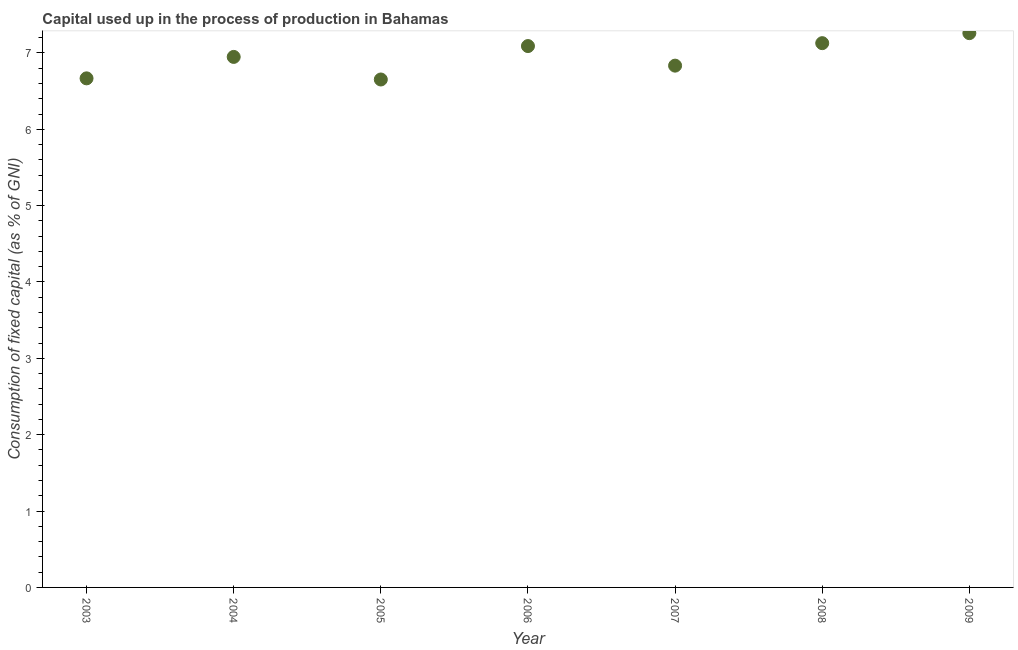What is the consumption of fixed capital in 2008?
Provide a succinct answer. 7.13. Across all years, what is the maximum consumption of fixed capital?
Provide a succinct answer. 7.26. Across all years, what is the minimum consumption of fixed capital?
Ensure brevity in your answer.  6.65. In which year was the consumption of fixed capital minimum?
Keep it short and to the point. 2005. What is the sum of the consumption of fixed capital?
Provide a succinct answer. 48.58. What is the difference between the consumption of fixed capital in 2005 and 2006?
Offer a very short reply. -0.44. What is the average consumption of fixed capital per year?
Ensure brevity in your answer.  6.94. What is the median consumption of fixed capital?
Your answer should be compact. 6.95. What is the ratio of the consumption of fixed capital in 2007 to that in 2009?
Provide a short and direct response. 0.94. Is the consumption of fixed capital in 2004 less than that in 2008?
Give a very brief answer. Yes. Is the difference between the consumption of fixed capital in 2005 and 2008 greater than the difference between any two years?
Give a very brief answer. No. What is the difference between the highest and the second highest consumption of fixed capital?
Make the answer very short. 0.13. What is the difference between the highest and the lowest consumption of fixed capital?
Offer a terse response. 0.61. In how many years, is the consumption of fixed capital greater than the average consumption of fixed capital taken over all years?
Give a very brief answer. 4. How many dotlines are there?
Your response must be concise. 1. What is the difference between two consecutive major ticks on the Y-axis?
Provide a succinct answer. 1. Are the values on the major ticks of Y-axis written in scientific E-notation?
Offer a very short reply. No. Does the graph contain any zero values?
Your answer should be very brief. No. Does the graph contain grids?
Give a very brief answer. No. What is the title of the graph?
Your answer should be compact. Capital used up in the process of production in Bahamas. What is the label or title of the Y-axis?
Ensure brevity in your answer.  Consumption of fixed capital (as % of GNI). What is the Consumption of fixed capital (as % of GNI) in 2003?
Your answer should be compact. 6.67. What is the Consumption of fixed capital (as % of GNI) in 2004?
Offer a terse response. 6.95. What is the Consumption of fixed capital (as % of GNI) in 2005?
Your response must be concise. 6.65. What is the Consumption of fixed capital (as % of GNI) in 2006?
Offer a terse response. 7.09. What is the Consumption of fixed capital (as % of GNI) in 2007?
Your answer should be compact. 6.83. What is the Consumption of fixed capital (as % of GNI) in 2008?
Offer a very short reply. 7.13. What is the Consumption of fixed capital (as % of GNI) in 2009?
Keep it short and to the point. 7.26. What is the difference between the Consumption of fixed capital (as % of GNI) in 2003 and 2004?
Offer a terse response. -0.28. What is the difference between the Consumption of fixed capital (as % of GNI) in 2003 and 2005?
Give a very brief answer. 0.01. What is the difference between the Consumption of fixed capital (as % of GNI) in 2003 and 2006?
Your response must be concise. -0.42. What is the difference between the Consumption of fixed capital (as % of GNI) in 2003 and 2007?
Provide a succinct answer. -0.17. What is the difference between the Consumption of fixed capital (as % of GNI) in 2003 and 2008?
Keep it short and to the point. -0.46. What is the difference between the Consumption of fixed capital (as % of GNI) in 2003 and 2009?
Ensure brevity in your answer.  -0.59. What is the difference between the Consumption of fixed capital (as % of GNI) in 2004 and 2005?
Your answer should be very brief. 0.3. What is the difference between the Consumption of fixed capital (as % of GNI) in 2004 and 2006?
Keep it short and to the point. -0.14. What is the difference between the Consumption of fixed capital (as % of GNI) in 2004 and 2007?
Your response must be concise. 0.11. What is the difference between the Consumption of fixed capital (as % of GNI) in 2004 and 2008?
Offer a terse response. -0.18. What is the difference between the Consumption of fixed capital (as % of GNI) in 2004 and 2009?
Provide a succinct answer. -0.31. What is the difference between the Consumption of fixed capital (as % of GNI) in 2005 and 2006?
Make the answer very short. -0.44. What is the difference between the Consumption of fixed capital (as % of GNI) in 2005 and 2007?
Keep it short and to the point. -0.18. What is the difference between the Consumption of fixed capital (as % of GNI) in 2005 and 2008?
Your answer should be compact. -0.48. What is the difference between the Consumption of fixed capital (as % of GNI) in 2005 and 2009?
Your response must be concise. -0.61. What is the difference between the Consumption of fixed capital (as % of GNI) in 2006 and 2007?
Offer a terse response. 0.26. What is the difference between the Consumption of fixed capital (as % of GNI) in 2006 and 2008?
Keep it short and to the point. -0.04. What is the difference between the Consumption of fixed capital (as % of GNI) in 2006 and 2009?
Provide a short and direct response. -0.17. What is the difference between the Consumption of fixed capital (as % of GNI) in 2007 and 2008?
Your response must be concise. -0.29. What is the difference between the Consumption of fixed capital (as % of GNI) in 2007 and 2009?
Your response must be concise. -0.43. What is the difference between the Consumption of fixed capital (as % of GNI) in 2008 and 2009?
Give a very brief answer. -0.13. What is the ratio of the Consumption of fixed capital (as % of GNI) in 2003 to that in 2006?
Provide a short and direct response. 0.94. What is the ratio of the Consumption of fixed capital (as % of GNI) in 2003 to that in 2007?
Make the answer very short. 0.98. What is the ratio of the Consumption of fixed capital (as % of GNI) in 2003 to that in 2008?
Your answer should be very brief. 0.94. What is the ratio of the Consumption of fixed capital (as % of GNI) in 2003 to that in 2009?
Provide a succinct answer. 0.92. What is the ratio of the Consumption of fixed capital (as % of GNI) in 2004 to that in 2005?
Make the answer very short. 1.04. What is the ratio of the Consumption of fixed capital (as % of GNI) in 2004 to that in 2006?
Provide a short and direct response. 0.98. What is the ratio of the Consumption of fixed capital (as % of GNI) in 2004 to that in 2009?
Your response must be concise. 0.96. What is the ratio of the Consumption of fixed capital (as % of GNI) in 2005 to that in 2006?
Provide a short and direct response. 0.94. What is the ratio of the Consumption of fixed capital (as % of GNI) in 2005 to that in 2008?
Ensure brevity in your answer.  0.93. What is the ratio of the Consumption of fixed capital (as % of GNI) in 2005 to that in 2009?
Offer a terse response. 0.92. What is the ratio of the Consumption of fixed capital (as % of GNI) in 2006 to that in 2007?
Your answer should be very brief. 1.04. What is the ratio of the Consumption of fixed capital (as % of GNI) in 2006 to that in 2008?
Ensure brevity in your answer.  0.99. What is the ratio of the Consumption of fixed capital (as % of GNI) in 2007 to that in 2008?
Offer a very short reply. 0.96. What is the ratio of the Consumption of fixed capital (as % of GNI) in 2007 to that in 2009?
Offer a very short reply. 0.94. What is the ratio of the Consumption of fixed capital (as % of GNI) in 2008 to that in 2009?
Make the answer very short. 0.98. 